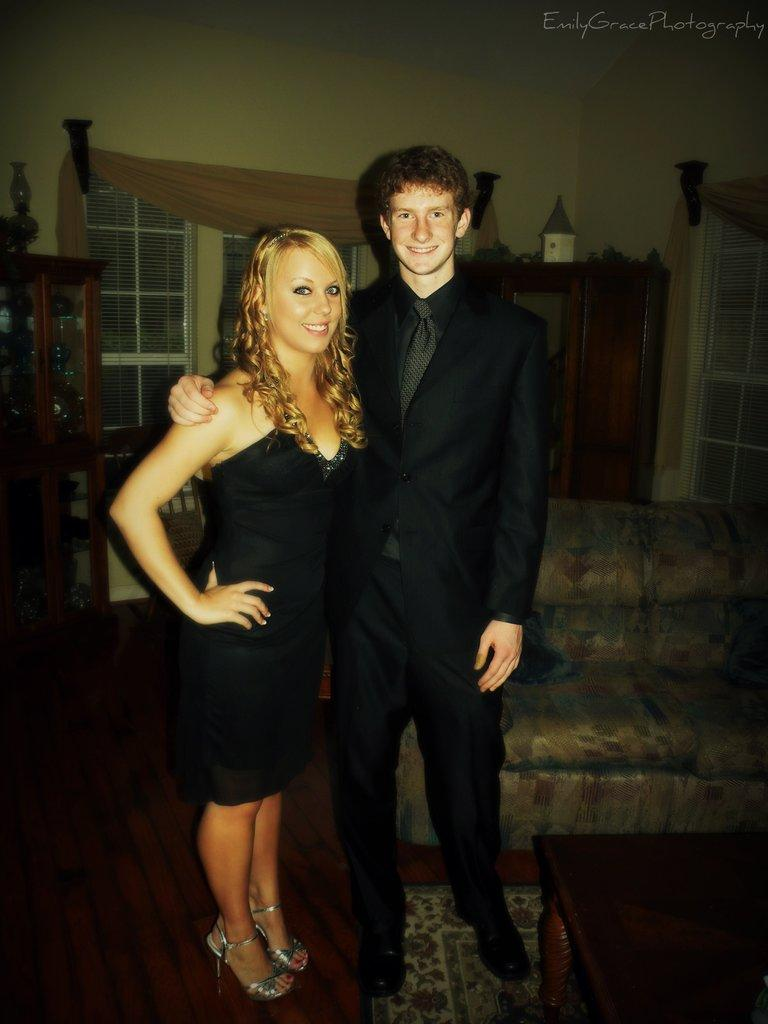Who are the two people in the center of the image? There is a man and a woman in the center of the image. What is the surface they are standing on? The man and woman are standing on the floor. What can be seen in the background of the image? There is a sofa, a cupboard, a window with a curtain, and a wall in the background of the image. What type of drain can be seen in the image? There is no drain present in the image. Can you provide an example of a development that took place in the room depicted in the image? There is no information about any development or changes that took place in the room; the image only shows the current state of the room. 